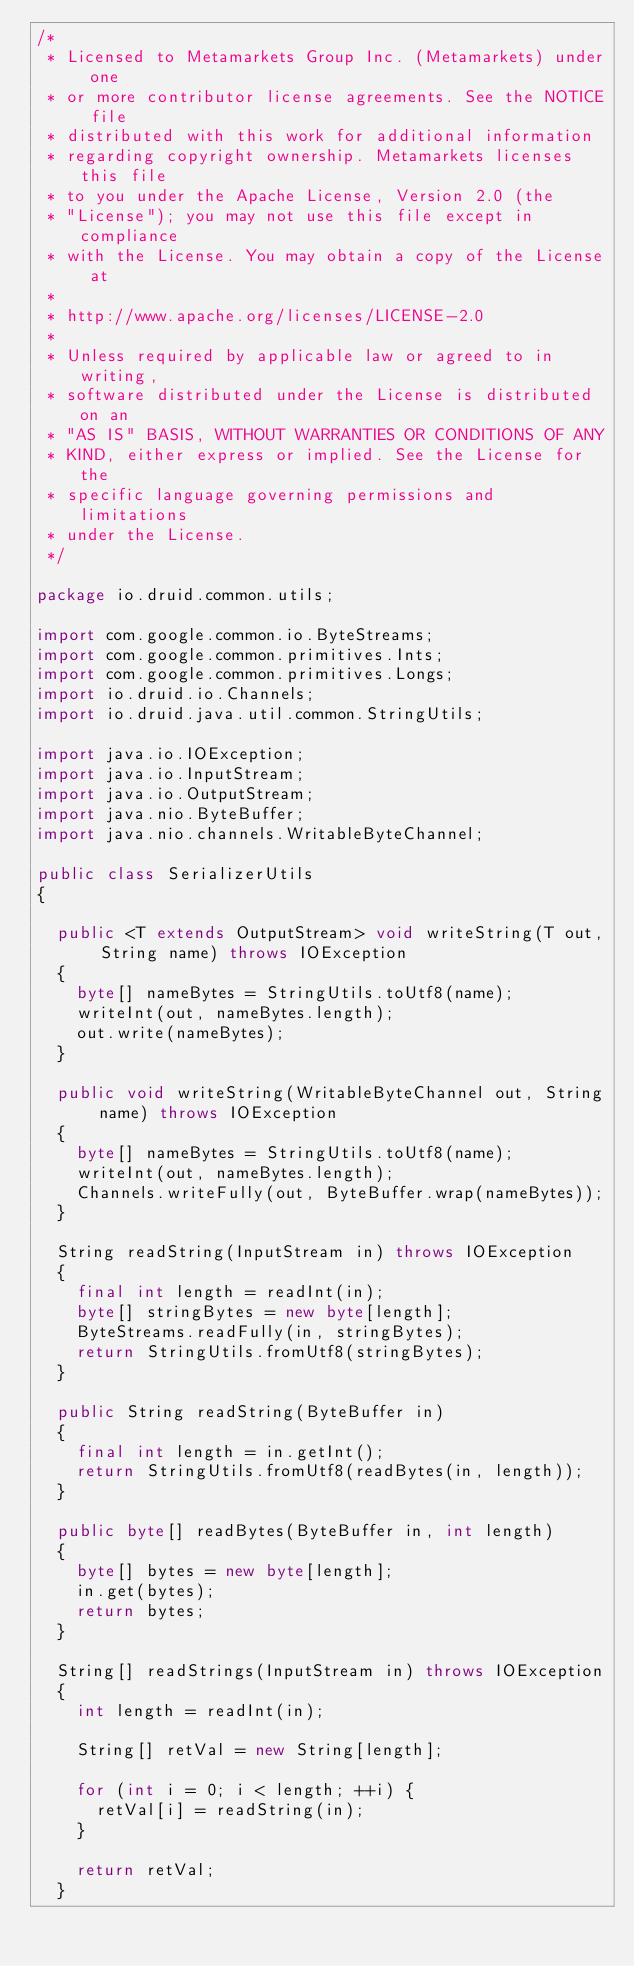Convert code to text. <code><loc_0><loc_0><loc_500><loc_500><_Java_>/*
 * Licensed to Metamarkets Group Inc. (Metamarkets) under one
 * or more contributor license agreements. See the NOTICE file
 * distributed with this work for additional information
 * regarding copyright ownership. Metamarkets licenses this file
 * to you under the Apache License, Version 2.0 (the
 * "License"); you may not use this file except in compliance
 * with the License. You may obtain a copy of the License at
 *
 * http://www.apache.org/licenses/LICENSE-2.0
 *
 * Unless required by applicable law or agreed to in writing,
 * software distributed under the License is distributed on an
 * "AS IS" BASIS, WITHOUT WARRANTIES OR CONDITIONS OF ANY
 * KIND, either express or implied. See the License for the
 * specific language governing permissions and limitations
 * under the License.
 */

package io.druid.common.utils;

import com.google.common.io.ByteStreams;
import com.google.common.primitives.Ints;
import com.google.common.primitives.Longs;
import io.druid.io.Channels;
import io.druid.java.util.common.StringUtils;

import java.io.IOException;
import java.io.InputStream;
import java.io.OutputStream;
import java.nio.ByteBuffer;
import java.nio.channels.WritableByteChannel;

public class SerializerUtils
{

  public <T extends OutputStream> void writeString(T out, String name) throws IOException
  {
    byte[] nameBytes = StringUtils.toUtf8(name);
    writeInt(out, nameBytes.length);
    out.write(nameBytes);
  }

  public void writeString(WritableByteChannel out, String name) throws IOException
  {
    byte[] nameBytes = StringUtils.toUtf8(name);
    writeInt(out, nameBytes.length);
    Channels.writeFully(out, ByteBuffer.wrap(nameBytes));
  }

  String readString(InputStream in) throws IOException
  {
    final int length = readInt(in);
    byte[] stringBytes = new byte[length];
    ByteStreams.readFully(in, stringBytes);
    return StringUtils.fromUtf8(stringBytes);
  }

  public String readString(ByteBuffer in)
  {
    final int length = in.getInt();
    return StringUtils.fromUtf8(readBytes(in, length));
  }
  
  public byte[] readBytes(ByteBuffer in, int length)
  {
    byte[] bytes = new byte[length];
    in.get(bytes);
    return bytes;
  }

  String[] readStrings(InputStream in) throws IOException
  {
    int length = readInt(in);

    String[] retVal = new String[length];

    for (int i = 0; i < length; ++i) {
      retVal[i] = readString(in);
    }

    return retVal;
  }
</code> 